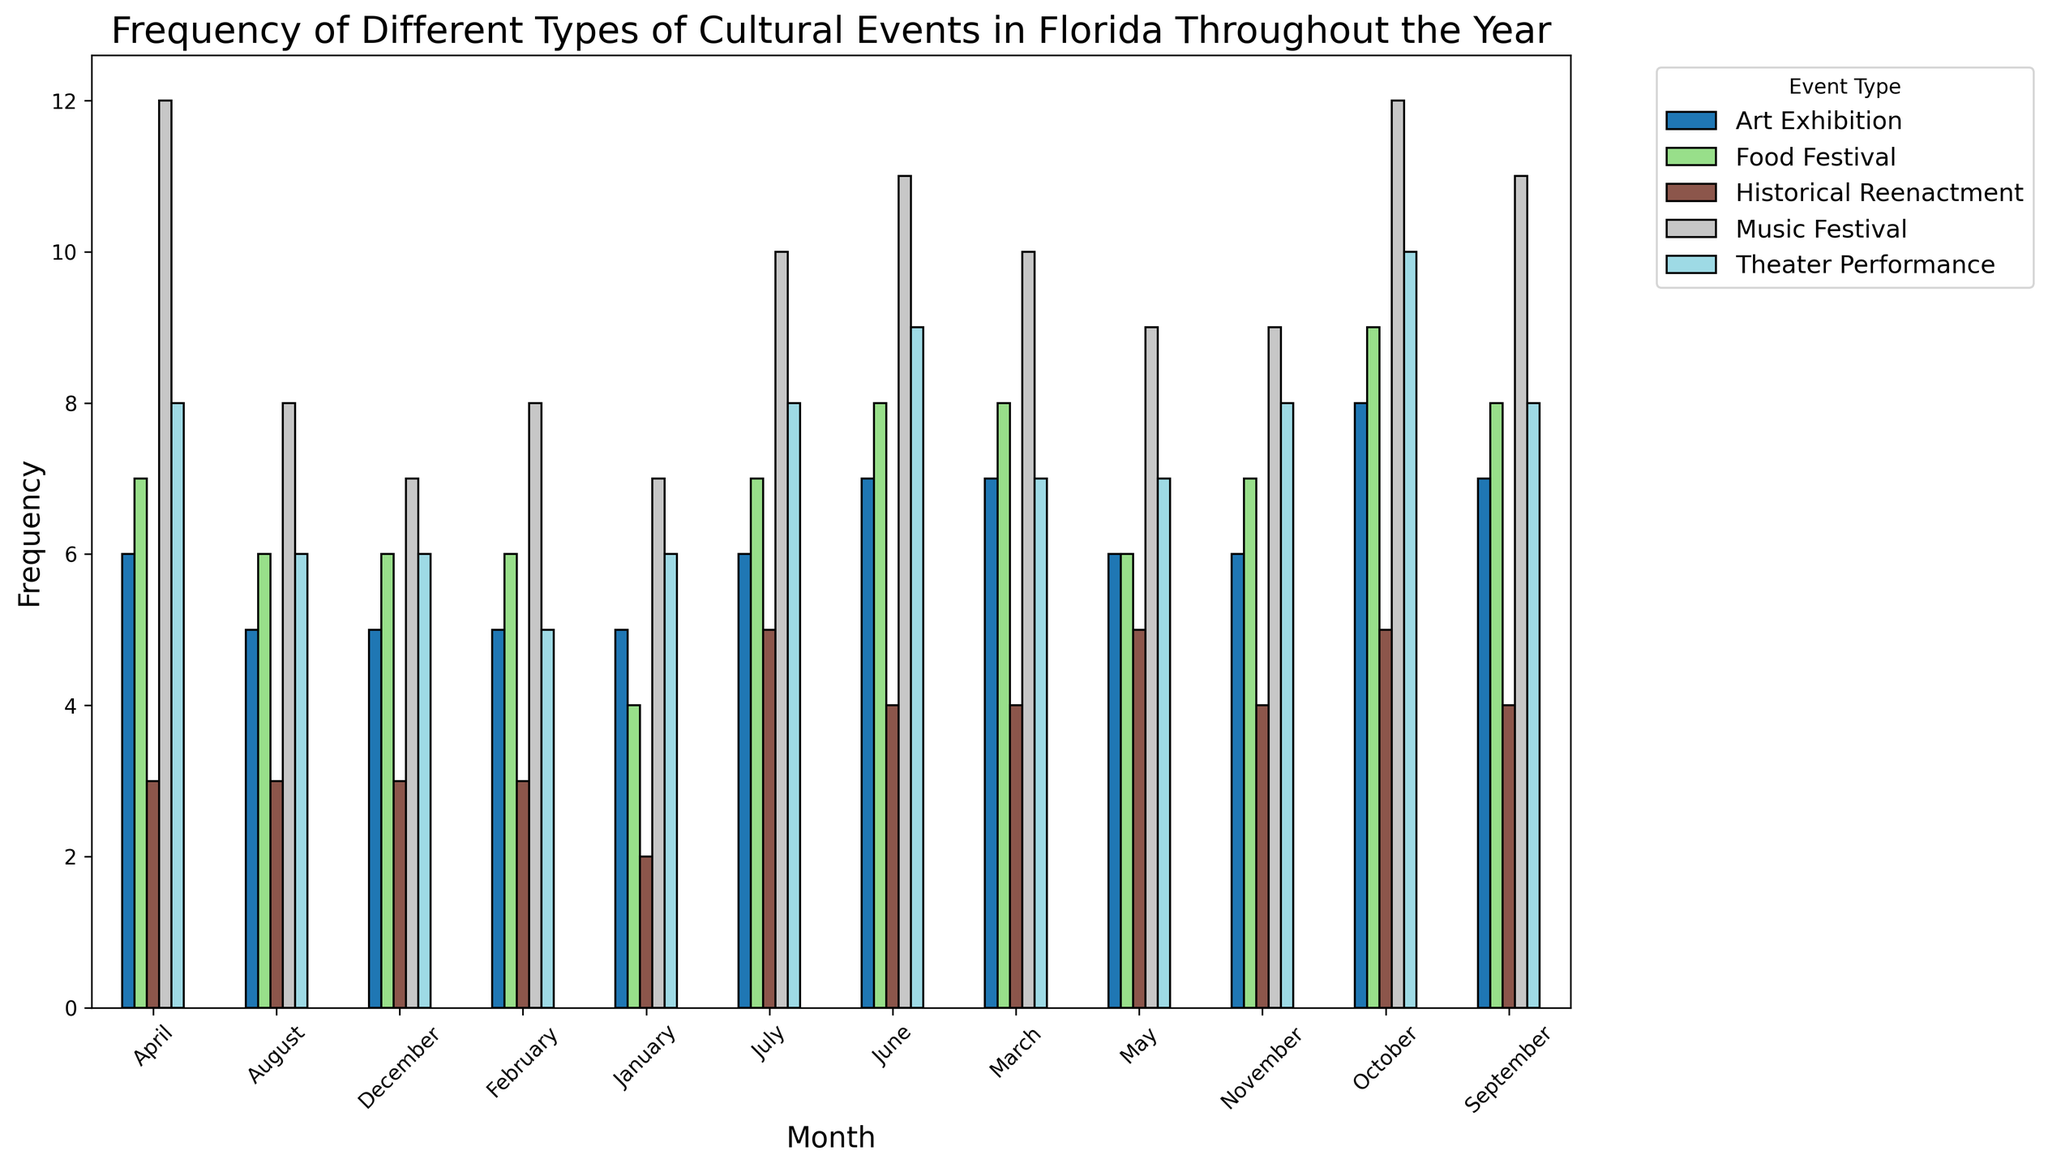How many Music Festivals were held in July and December combined? To find out the total number of Music Festivals in July and December, look at the bar heights for Music Festivals in these months and add their frequencies. For July, it's 10, and for December, it's 7. So, 10 + 7 = 17.
Answer: 17 Which month has the highest frequency of Theater Performances? To identify the month with the highest frequency of Theater Performances, compare the heights of the corresponding bars for each month. The tallest Theater Performance bar is in October with a frequency of 10.
Answer: October Is the frequency of Food Festivals in March greater than in June? Compare the bars for Food Festivals in March and June. The height for March is 8, while the height for June is also 8. Since both are equal, it is not greater.
Answer: No What is the average frequency of Art Exhibitions across all months? Add the frequencies of Art Exhibitions for all months and then divide by the number of months. (5+5+7+6+6+7+6+5+7+8+6+5) = 73. There are 12 months, so 73 / 12 ≈ 6.08.
Answer: 6.08 Which month has the least number of Historical Reenactments? Scan for the shortest bars in the Historical Reenactment category. January has the shortest bar with a frequency of 2.
Answer: January Between April and October, in which month were more total cultural events held? To compare, sum the frequencies of all event types for April and October. April: 12 (Music) + 6 (Art) + 7 (Food) + 3 (Historical) + 8 (Theater) = 36. October: 12 (Music) + 8 (Art) + 9 (Food) + 5 (Historical) + 10 (Theater) = 44. Since 44 > 36, October has more total events.
Answer: October Which event type generally has the highest frequency throughout the year? Look at the overall height pattern of bars across the months for each event type. Music Festivals generally have the highest frequencies compared to other event types.
Answer: Music Festivals How many more Theater Performances were there in October compared to March? Check the bar heights for Theater Performances in October and March. October has 10, and March has 7. To find the difference, subtract 7 from 10, which gives 3.
Answer: 3 What is the frequency difference between Food Festivals in February and November? Compare the heights of the bars for Food Festivals in February and November. February has 6, and November has 7. The difference is 7 - 6 = 1.
Answer: 1 